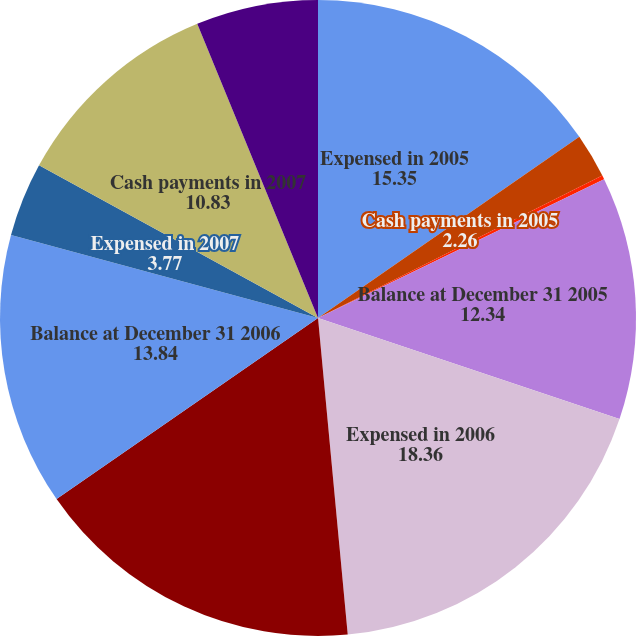Convert chart. <chart><loc_0><loc_0><loc_500><loc_500><pie_chart><fcel>Expensed in 2005<fcel>Cash payments in 2005<fcel>Foreign currency revaluation<fcel>Balance at December 31 2005<fcel>Expensed in 2006<fcel>Cash payments in 2006<fcel>Balance at December 31 2006<fcel>Expensed in 2007<fcel>Cash payments in 2007<fcel>Balance at December 31 2007<nl><fcel>15.35%<fcel>2.26%<fcel>0.2%<fcel>12.34%<fcel>18.36%<fcel>16.85%<fcel>13.84%<fcel>3.77%<fcel>10.83%<fcel>6.2%<nl></chart> 